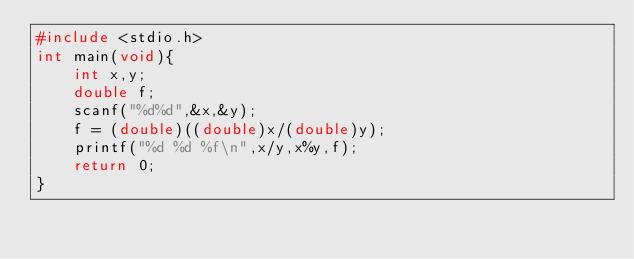<code> <loc_0><loc_0><loc_500><loc_500><_C_>#include <stdio.h>
int main(void){
    int x,y;
    double f;
    scanf("%d%d",&x,&y);
    f = (double)((double)x/(double)y);
    printf("%d %d %f\n",x/y,x%y,f);
    return 0;
}
</code> 